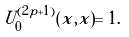Convert formula to latex. <formula><loc_0><loc_0><loc_500><loc_500>U ^ { ( 2 p + 1 ) } _ { 0 } ( x , x ) = 1 .</formula> 